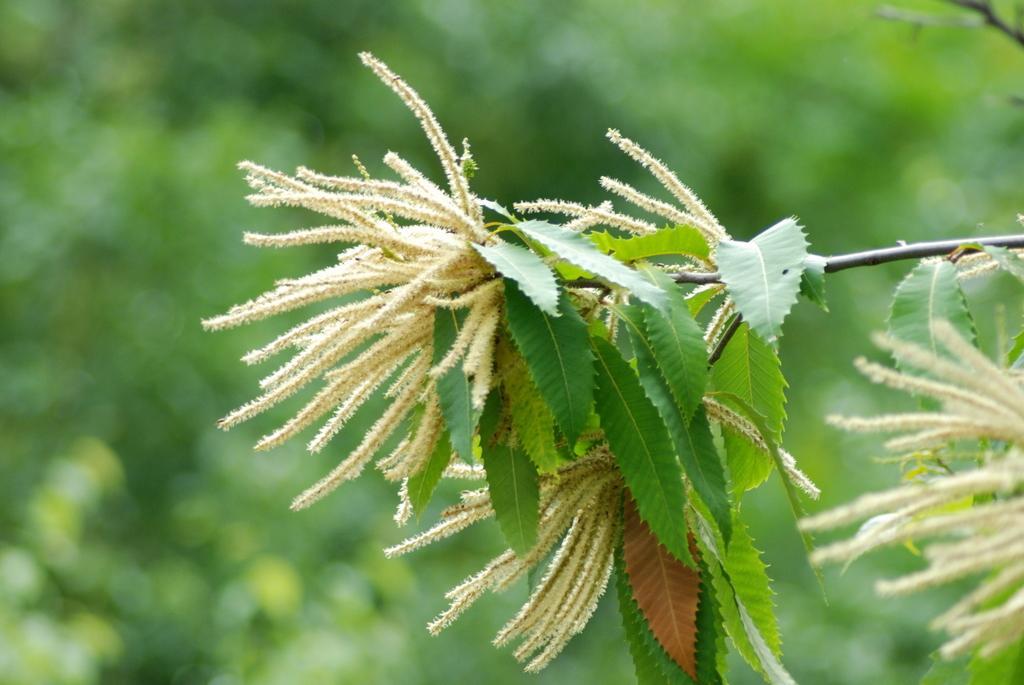Can you describe this image briefly? In this picture, we see the tree and we see something in white color. It might be the flowers. In the background, it is green in color. This picture is blurred in the background. 